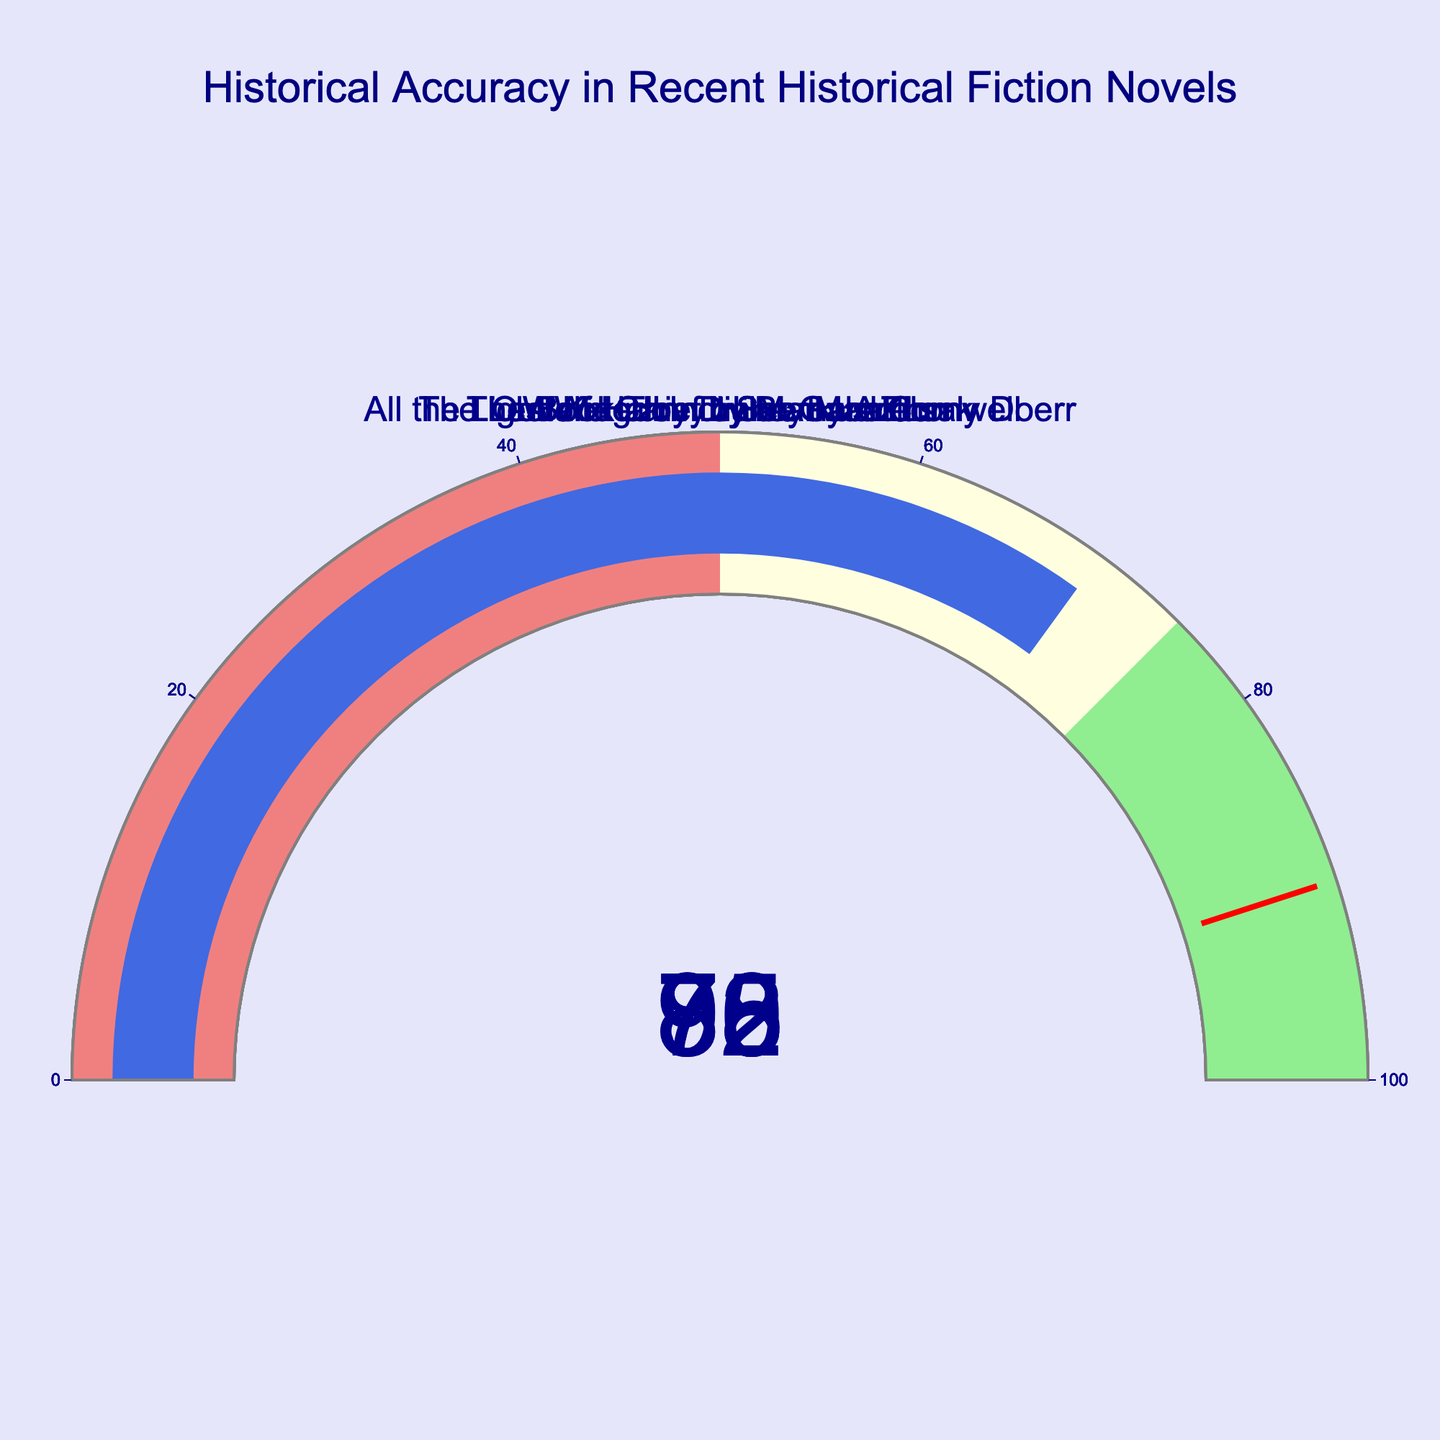What is the historical accuracy percentage of "The Book Thief" by Markus Zusak? To find this, look at the gauge displaying the historical accuracy for "The Book Thief". The gauge shows a value of 78.
Answer: 78 How many novels have a historical accuracy of 85 or higher? To answer this, count the gauge charts that display values of 85 or above. The novels are "The Last Kingdom" (85), "Wolf Hall" (92), and "All the Light We Cannot See" (88). That makes three novels.
Answer: 3 Which novel has the highest historical accuracy? Look for the gauge with the highest percentage. "Wolf Hall" by Hilary Mantel has the highest accuracy at 92.
Answer: "Wolf Hall" by Hilary Mantel What is the average historical accuracy percentage across the novels? To calculate the average, add the historical accuracy percentages (85 + 92 + 78 + 88 + 70) and divide by the number of novels (5). The sum is 413, and the average is 413 / 5 = 82.6.
Answer: 82.6 Which novels fall into the "lightgreen" zone (75-100%) in terms of historical accuracy? Identify the novels whose gauges fall in the 75-100% range by checking their displayed values. The novels are "The Last Kingdom" (85), "Wolf Hall" (92), "The Book Thief" (78), and "All the Light We Cannot See" (88).
Answer: "The Last Kingdom", "Wolf Hall", "The Book Thief", "All the Light We Cannot See" What is the range of the historical accuracy percentages shown in the figure? To find the range, subtract the lowest percentage from the highest percentage. The highest is 92 (from "Wolf Hall") and the lowest is 70 (from "Outlander"). So, the range is 92 - 70 = 22.
Answer: 22 Does any novel have a historical accuracy exactly at the threshold value set at 90? Check if any gauge displays the value 90. None of the novels have a gauge that reads exactly 90.
Answer: No Which novel has the lowest historical accuracy? Locate the gauge with the smallest percentage. "Outlander" by Diana Gabaldon has the lowest accuracy at 70.
Answer: "Outlander" by Diana Gabaldon How many novels fall into the "lightcoral" zone (0-50%)? Look for gauges with values between 0 and 50. None of the gauges fall into this range.
Answer: 0 